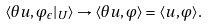<formula> <loc_0><loc_0><loc_500><loc_500>\langle \theta u , \varphi _ { \epsilon } | _ { U } \rangle \to \langle \theta u , \varphi \rangle = \langle u , \varphi \rangle .</formula> 